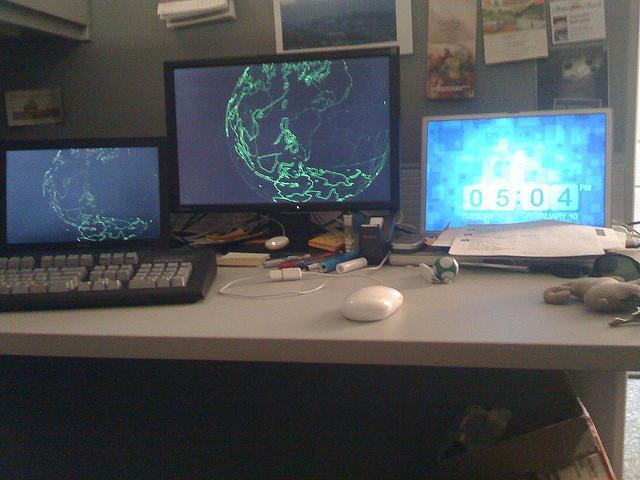What does the white mouse on the table do?
Make your selection from the four choices given to correctly answer the question.
Options: Control computers, food, listening device, glasses. Control computers. 